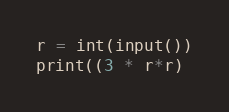Convert code to text. <code><loc_0><loc_0><loc_500><loc_500><_Python_>r = int(input())
print((3 * r*r)</code> 